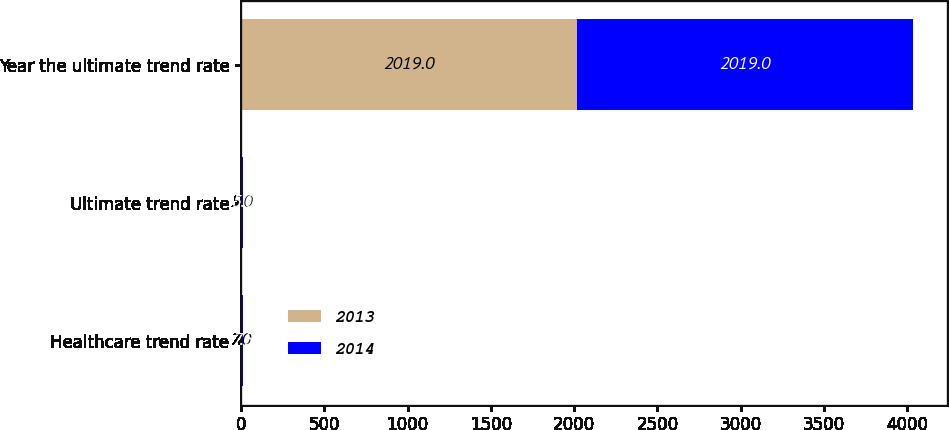Convert chart. <chart><loc_0><loc_0><loc_500><loc_500><stacked_bar_chart><ecel><fcel>Healthcare trend rate<fcel>Ultimate trend rate<fcel>Year the ultimate trend rate<nl><fcel>2013<fcel>7<fcel>5<fcel>2019<nl><fcel>2014<fcel>7.5<fcel>5<fcel>2019<nl></chart> 